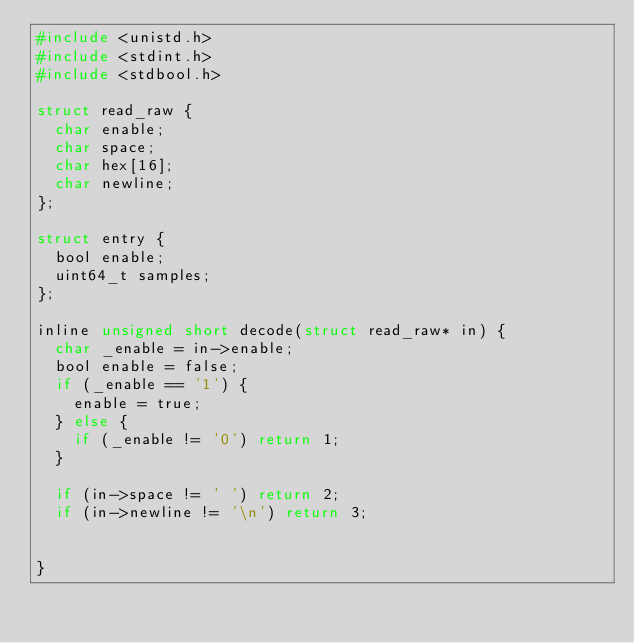<code> <loc_0><loc_0><loc_500><loc_500><_C_>#include <unistd.h>
#include <stdint.h>
#include <stdbool.h>

struct read_raw {
	char enable;
	char space;
	char hex[16];
	char newline;
};

struct entry {
	bool enable;
	uint64_t samples;
};

inline unsigned short decode(struct read_raw* in) {
	char _enable = in->enable;
	bool enable = false;
	if (_enable == '1') {
		enable = true;
	} else {
		if (_enable != '0') return 1;
	}

	if (in->space != ' ') return 2;
	if (in->newline != '\n') return 3;

	
}


</code> 